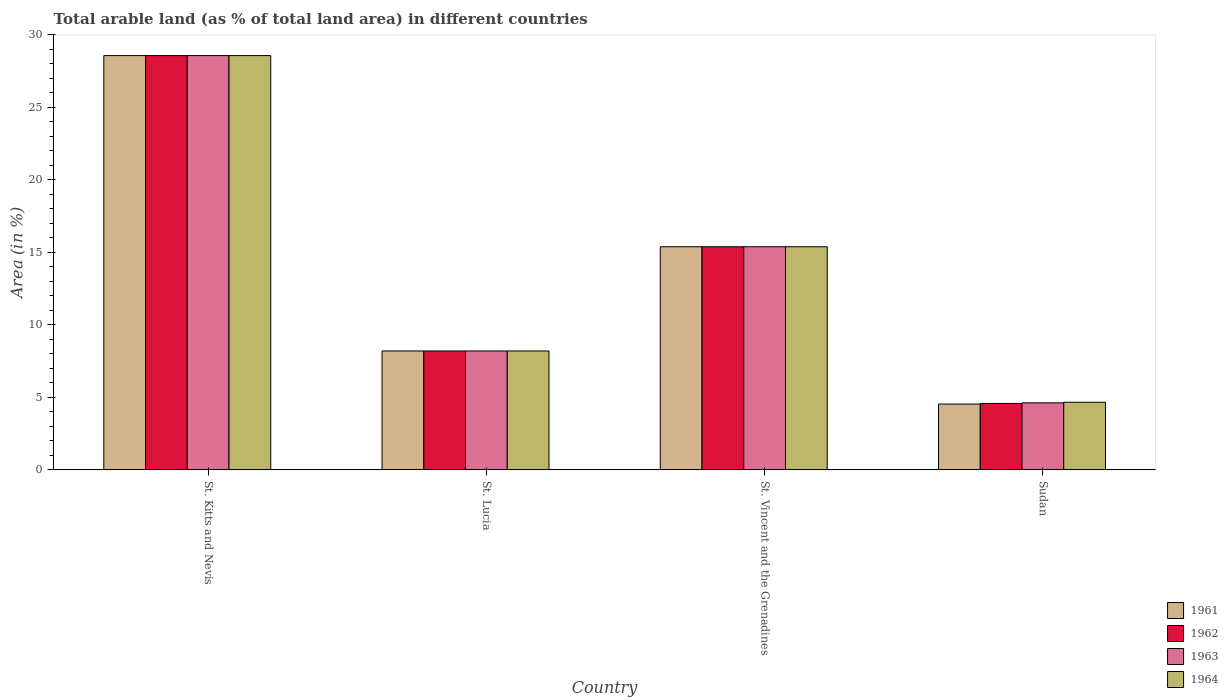How many different coloured bars are there?
Keep it short and to the point. 4. How many groups of bars are there?
Keep it short and to the point. 4. Are the number of bars per tick equal to the number of legend labels?
Offer a very short reply. Yes. How many bars are there on the 2nd tick from the left?
Ensure brevity in your answer.  4. What is the label of the 4th group of bars from the left?
Give a very brief answer. Sudan. In how many cases, is the number of bars for a given country not equal to the number of legend labels?
Provide a succinct answer. 0. What is the percentage of arable land in 1964 in St. Lucia?
Your response must be concise. 8.2. Across all countries, what is the maximum percentage of arable land in 1963?
Offer a terse response. 28.57. Across all countries, what is the minimum percentage of arable land in 1963?
Give a very brief answer. 4.62. In which country was the percentage of arable land in 1964 maximum?
Your answer should be compact. St. Kitts and Nevis. In which country was the percentage of arable land in 1963 minimum?
Give a very brief answer. Sudan. What is the total percentage of arable land in 1963 in the graph?
Make the answer very short. 56.77. What is the difference between the percentage of arable land in 1964 in St. Vincent and the Grenadines and that in Sudan?
Give a very brief answer. 10.72. What is the difference between the percentage of arable land in 1961 in St. Vincent and the Grenadines and the percentage of arable land in 1964 in St. Kitts and Nevis?
Make the answer very short. -13.19. What is the average percentage of arable land in 1963 per country?
Your answer should be very brief. 14.19. What is the difference between the percentage of arable land of/in 1961 and percentage of arable land of/in 1962 in Sudan?
Your answer should be compact. -0.04. In how many countries, is the percentage of arable land in 1964 greater than 23 %?
Your response must be concise. 1. What is the ratio of the percentage of arable land in 1961 in St. Lucia to that in St. Vincent and the Grenadines?
Ensure brevity in your answer.  0.53. What is the difference between the highest and the second highest percentage of arable land in 1962?
Provide a short and direct response. -20.37. What is the difference between the highest and the lowest percentage of arable land in 1961?
Provide a succinct answer. 24.04. In how many countries, is the percentage of arable land in 1964 greater than the average percentage of arable land in 1964 taken over all countries?
Your response must be concise. 2. Is the sum of the percentage of arable land in 1963 in St. Lucia and St. Vincent and the Grenadines greater than the maximum percentage of arable land in 1964 across all countries?
Keep it short and to the point. No. What does the 3rd bar from the left in St. Kitts and Nevis represents?
Your response must be concise. 1963. What does the 1st bar from the right in St. Lucia represents?
Your response must be concise. 1964. What is the difference between two consecutive major ticks on the Y-axis?
Give a very brief answer. 5. Does the graph contain any zero values?
Your answer should be very brief. No. What is the title of the graph?
Keep it short and to the point. Total arable land (as % of total land area) in different countries. What is the label or title of the X-axis?
Offer a very short reply. Country. What is the label or title of the Y-axis?
Keep it short and to the point. Area (in %). What is the Area (in %) of 1961 in St. Kitts and Nevis?
Offer a terse response. 28.57. What is the Area (in %) of 1962 in St. Kitts and Nevis?
Your answer should be compact. 28.57. What is the Area (in %) in 1963 in St. Kitts and Nevis?
Ensure brevity in your answer.  28.57. What is the Area (in %) of 1964 in St. Kitts and Nevis?
Your answer should be compact. 28.57. What is the Area (in %) in 1961 in St. Lucia?
Make the answer very short. 8.2. What is the Area (in %) in 1962 in St. Lucia?
Keep it short and to the point. 8.2. What is the Area (in %) of 1963 in St. Lucia?
Provide a short and direct response. 8.2. What is the Area (in %) of 1964 in St. Lucia?
Give a very brief answer. 8.2. What is the Area (in %) of 1961 in St. Vincent and the Grenadines?
Ensure brevity in your answer.  15.38. What is the Area (in %) in 1962 in St. Vincent and the Grenadines?
Offer a terse response. 15.38. What is the Area (in %) of 1963 in St. Vincent and the Grenadines?
Provide a short and direct response. 15.38. What is the Area (in %) of 1964 in St. Vincent and the Grenadines?
Your answer should be compact. 15.38. What is the Area (in %) of 1961 in Sudan?
Your response must be concise. 4.53. What is the Area (in %) of 1962 in Sudan?
Make the answer very short. 4.58. What is the Area (in %) in 1963 in Sudan?
Provide a succinct answer. 4.62. What is the Area (in %) in 1964 in Sudan?
Give a very brief answer. 4.66. Across all countries, what is the maximum Area (in %) of 1961?
Give a very brief answer. 28.57. Across all countries, what is the maximum Area (in %) of 1962?
Keep it short and to the point. 28.57. Across all countries, what is the maximum Area (in %) in 1963?
Provide a short and direct response. 28.57. Across all countries, what is the maximum Area (in %) in 1964?
Ensure brevity in your answer.  28.57. Across all countries, what is the minimum Area (in %) of 1961?
Provide a short and direct response. 4.53. Across all countries, what is the minimum Area (in %) of 1962?
Provide a succinct answer. 4.58. Across all countries, what is the minimum Area (in %) in 1963?
Give a very brief answer. 4.62. Across all countries, what is the minimum Area (in %) in 1964?
Your answer should be compact. 4.66. What is the total Area (in %) in 1961 in the graph?
Keep it short and to the point. 56.69. What is the total Area (in %) in 1962 in the graph?
Provide a short and direct response. 56.73. What is the total Area (in %) in 1963 in the graph?
Your response must be concise. 56.77. What is the total Area (in %) of 1964 in the graph?
Provide a succinct answer. 56.81. What is the difference between the Area (in %) of 1961 in St. Kitts and Nevis and that in St. Lucia?
Your answer should be compact. 20.37. What is the difference between the Area (in %) of 1962 in St. Kitts and Nevis and that in St. Lucia?
Provide a succinct answer. 20.37. What is the difference between the Area (in %) in 1963 in St. Kitts and Nevis and that in St. Lucia?
Your response must be concise. 20.37. What is the difference between the Area (in %) of 1964 in St. Kitts and Nevis and that in St. Lucia?
Your answer should be very brief. 20.37. What is the difference between the Area (in %) in 1961 in St. Kitts and Nevis and that in St. Vincent and the Grenadines?
Give a very brief answer. 13.19. What is the difference between the Area (in %) of 1962 in St. Kitts and Nevis and that in St. Vincent and the Grenadines?
Ensure brevity in your answer.  13.19. What is the difference between the Area (in %) in 1963 in St. Kitts and Nevis and that in St. Vincent and the Grenadines?
Provide a short and direct response. 13.19. What is the difference between the Area (in %) of 1964 in St. Kitts and Nevis and that in St. Vincent and the Grenadines?
Provide a short and direct response. 13.19. What is the difference between the Area (in %) of 1961 in St. Kitts and Nevis and that in Sudan?
Your response must be concise. 24.04. What is the difference between the Area (in %) in 1962 in St. Kitts and Nevis and that in Sudan?
Your answer should be very brief. 23.99. What is the difference between the Area (in %) in 1963 in St. Kitts and Nevis and that in Sudan?
Ensure brevity in your answer.  23.95. What is the difference between the Area (in %) in 1964 in St. Kitts and Nevis and that in Sudan?
Your answer should be very brief. 23.91. What is the difference between the Area (in %) in 1961 in St. Lucia and that in St. Vincent and the Grenadines?
Your response must be concise. -7.19. What is the difference between the Area (in %) in 1962 in St. Lucia and that in St. Vincent and the Grenadines?
Your response must be concise. -7.19. What is the difference between the Area (in %) of 1963 in St. Lucia and that in St. Vincent and the Grenadines?
Make the answer very short. -7.19. What is the difference between the Area (in %) of 1964 in St. Lucia and that in St. Vincent and the Grenadines?
Ensure brevity in your answer.  -7.19. What is the difference between the Area (in %) in 1961 in St. Lucia and that in Sudan?
Offer a very short reply. 3.66. What is the difference between the Area (in %) in 1962 in St. Lucia and that in Sudan?
Ensure brevity in your answer.  3.62. What is the difference between the Area (in %) in 1963 in St. Lucia and that in Sudan?
Provide a short and direct response. 3.58. What is the difference between the Area (in %) of 1964 in St. Lucia and that in Sudan?
Keep it short and to the point. 3.54. What is the difference between the Area (in %) in 1961 in St. Vincent and the Grenadines and that in Sudan?
Ensure brevity in your answer.  10.85. What is the difference between the Area (in %) of 1962 in St. Vincent and the Grenadines and that in Sudan?
Your answer should be compact. 10.81. What is the difference between the Area (in %) in 1963 in St. Vincent and the Grenadines and that in Sudan?
Give a very brief answer. 10.77. What is the difference between the Area (in %) in 1964 in St. Vincent and the Grenadines and that in Sudan?
Ensure brevity in your answer.  10.72. What is the difference between the Area (in %) of 1961 in St. Kitts and Nevis and the Area (in %) of 1962 in St. Lucia?
Your response must be concise. 20.37. What is the difference between the Area (in %) in 1961 in St. Kitts and Nevis and the Area (in %) in 1963 in St. Lucia?
Offer a very short reply. 20.37. What is the difference between the Area (in %) of 1961 in St. Kitts and Nevis and the Area (in %) of 1964 in St. Lucia?
Your answer should be very brief. 20.37. What is the difference between the Area (in %) of 1962 in St. Kitts and Nevis and the Area (in %) of 1963 in St. Lucia?
Offer a very short reply. 20.37. What is the difference between the Area (in %) of 1962 in St. Kitts and Nevis and the Area (in %) of 1964 in St. Lucia?
Your response must be concise. 20.37. What is the difference between the Area (in %) in 1963 in St. Kitts and Nevis and the Area (in %) in 1964 in St. Lucia?
Your answer should be compact. 20.37. What is the difference between the Area (in %) in 1961 in St. Kitts and Nevis and the Area (in %) in 1962 in St. Vincent and the Grenadines?
Offer a terse response. 13.19. What is the difference between the Area (in %) of 1961 in St. Kitts and Nevis and the Area (in %) of 1963 in St. Vincent and the Grenadines?
Your response must be concise. 13.19. What is the difference between the Area (in %) of 1961 in St. Kitts and Nevis and the Area (in %) of 1964 in St. Vincent and the Grenadines?
Your answer should be compact. 13.19. What is the difference between the Area (in %) of 1962 in St. Kitts and Nevis and the Area (in %) of 1963 in St. Vincent and the Grenadines?
Offer a terse response. 13.19. What is the difference between the Area (in %) of 1962 in St. Kitts and Nevis and the Area (in %) of 1964 in St. Vincent and the Grenadines?
Keep it short and to the point. 13.19. What is the difference between the Area (in %) of 1963 in St. Kitts and Nevis and the Area (in %) of 1964 in St. Vincent and the Grenadines?
Keep it short and to the point. 13.19. What is the difference between the Area (in %) in 1961 in St. Kitts and Nevis and the Area (in %) in 1962 in Sudan?
Make the answer very short. 23.99. What is the difference between the Area (in %) in 1961 in St. Kitts and Nevis and the Area (in %) in 1963 in Sudan?
Offer a terse response. 23.95. What is the difference between the Area (in %) in 1961 in St. Kitts and Nevis and the Area (in %) in 1964 in Sudan?
Offer a very short reply. 23.91. What is the difference between the Area (in %) in 1962 in St. Kitts and Nevis and the Area (in %) in 1963 in Sudan?
Make the answer very short. 23.95. What is the difference between the Area (in %) in 1962 in St. Kitts and Nevis and the Area (in %) in 1964 in Sudan?
Your answer should be very brief. 23.91. What is the difference between the Area (in %) in 1963 in St. Kitts and Nevis and the Area (in %) in 1964 in Sudan?
Make the answer very short. 23.91. What is the difference between the Area (in %) in 1961 in St. Lucia and the Area (in %) in 1962 in St. Vincent and the Grenadines?
Ensure brevity in your answer.  -7.19. What is the difference between the Area (in %) in 1961 in St. Lucia and the Area (in %) in 1963 in St. Vincent and the Grenadines?
Your answer should be very brief. -7.19. What is the difference between the Area (in %) in 1961 in St. Lucia and the Area (in %) in 1964 in St. Vincent and the Grenadines?
Your answer should be compact. -7.19. What is the difference between the Area (in %) in 1962 in St. Lucia and the Area (in %) in 1963 in St. Vincent and the Grenadines?
Keep it short and to the point. -7.19. What is the difference between the Area (in %) in 1962 in St. Lucia and the Area (in %) in 1964 in St. Vincent and the Grenadines?
Ensure brevity in your answer.  -7.19. What is the difference between the Area (in %) of 1963 in St. Lucia and the Area (in %) of 1964 in St. Vincent and the Grenadines?
Provide a short and direct response. -7.19. What is the difference between the Area (in %) in 1961 in St. Lucia and the Area (in %) in 1962 in Sudan?
Ensure brevity in your answer.  3.62. What is the difference between the Area (in %) in 1961 in St. Lucia and the Area (in %) in 1963 in Sudan?
Your response must be concise. 3.58. What is the difference between the Area (in %) of 1961 in St. Lucia and the Area (in %) of 1964 in Sudan?
Offer a very short reply. 3.54. What is the difference between the Area (in %) in 1962 in St. Lucia and the Area (in %) in 1963 in Sudan?
Make the answer very short. 3.58. What is the difference between the Area (in %) in 1962 in St. Lucia and the Area (in %) in 1964 in Sudan?
Give a very brief answer. 3.54. What is the difference between the Area (in %) of 1963 in St. Lucia and the Area (in %) of 1964 in Sudan?
Your answer should be very brief. 3.54. What is the difference between the Area (in %) in 1961 in St. Vincent and the Grenadines and the Area (in %) in 1962 in Sudan?
Your answer should be compact. 10.81. What is the difference between the Area (in %) of 1961 in St. Vincent and the Grenadines and the Area (in %) of 1963 in Sudan?
Give a very brief answer. 10.77. What is the difference between the Area (in %) of 1961 in St. Vincent and the Grenadines and the Area (in %) of 1964 in Sudan?
Your answer should be compact. 10.72. What is the difference between the Area (in %) of 1962 in St. Vincent and the Grenadines and the Area (in %) of 1963 in Sudan?
Provide a short and direct response. 10.77. What is the difference between the Area (in %) of 1962 in St. Vincent and the Grenadines and the Area (in %) of 1964 in Sudan?
Provide a short and direct response. 10.72. What is the difference between the Area (in %) in 1963 in St. Vincent and the Grenadines and the Area (in %) in 1964 in Sudan?
Make the answer very short. 10.72. What is the average Area (in %) of 1961 per country?
Offer a very short reply. 14.17. What is the average Area (in %) of 1962 per country?
Provide a succinct answer. 14.18. What is the average Area (in %) in 1963 per country?
Your answer should be very brief. 14.19. What is the average Area (in %) of 1964 per country?
Keep it short and to the point. 14.2. What is the difference between the Area (in %) in 1962 and Area (in %) in 1963 in St. Kitts and Nevis?
Offer a very short reply. 0. What is the difference between the Area (in %) of 1962 and Area (in %) of 1964 in St. Kitts and Nevis?
Make the answer very short. 0. What is the difference between the Area (in %) in 1961 and Area (in %) in 1962 in St. Lucia?
Ensure brevity in your answer.  0. What is the difference between the Area (in %) of 1961 and Area (in %) of 1963 in St. Lucia?
Your answer should be very brief. 0. What is the difference between the Area (in %) in 1961 and Area (in %) in 1964 in St. Lucia?
Keep it short and to the point. 0. What is the difference between the Area (in %) of 1962 and Area (in %) of 1964 in St. Lucia?
Keep it short and to the point. 0. What is the difference between the Area (in %) in 1961 and Area (in %) in 1962 in St. Vincent and the Grenadines?
Ensure brevity in your answer.  0. What is the difference between the Area (in %) of 1961 and Area (in %) of 1963 in St. Vincent and the Grenadines?
Offer a very short reply. 0. What is the difference between the Area (in %) in 1962 and Area (in %) in 1963 in St. Vincent and the Grenadines?
Your response must be concise. 0. What is the difference between the Area (in %) in 1962 and Area (in %) in 1964 in St. Vincent and the Grenadines?
Offer a terse response. 0. What is the difference between the Area (in %) in 1963 and Area (in %) in 1964 in St. Vincent and the Grenadines?
Your answer should be very brief. 0. What is the difference between the Area (in %) in 1961 and Area (in %) in 1962 in Sudan?
Your answer should be compact. -0.04. What is the difference between the Area (in %) of 1961 and Area (in %) of 1963 in Sudan?
Provide a short and direct response. -0.08. What is the difference between the Area (in %) of 1961 and Area (in %) of 1964 in Sudan?
Provide a short and direct response. -0.12. What is the difference between the Area (in %) in 1962 and Area (in %) in 1963 in Sudan?
Make the answer very short. -0.04. What is the difference between the Area (in %) of 1962 and Area (in %) of 1964 in Sudan?
Ensure brevity in your answer.  -0.08. What is the difference between the Area (in %) of 1963 and Area (in %) of 1964 in Sudan?
Give a very brief answer. -0.04. What is the ratio of the Area (in %) of 1961 in St. Kitts and Nevis to that in St. Lucia?
Your answer should be very brief. 3.49. What is the ratio of the Area (in %) in 1962 in St. Kitts and Nevis to that in St. Lucia?
Offer a very short reply. 3.49. What is the ratio of the Area (in %) in 1963 in St. Kitts and Nevis to that in St. Lucia?
Offer a very short reply. 3.49. What is the ratio of the Area (in %) in 1964 in St. Kitts and Nevis to that in St. Lucia?
Make the answer very short. 3.49. What is the ratio of the Area (in %) of 1961 in St. Kitts and Nevis to that in St. Vincent and the Grenadines?
Provide a succinct answer. 1.86. What is the ratio of the Area (in %) in 1962 in St. Kitts and Nevis to that in St. Vincent and the Grenadines?
Your response must be concise. 1.86. What is the ratio of the Area (in %) of 1963 in St. Kitts and Nevis to that in St. Vincent and the Grenadines?
Your answer should be compact. 1.86. What is the ratio of the Area (in %) of 1964 in St. Kitts and Nevis to that in St. Vincent and the Grenadines?
Ensure brevity in your answer.  1.86. What is the ratio of the Area (in %) of 1961 in St. Kitts and Nevis to that in Sudan?
Give a very brief answer. 6.3. What is the ratio of the Area (in %) of 1962 in St. Kitts and Nevis to that in Sudan?
Your answer should be very brief. 6.24. What is the ratio of the Area (in %) in 1963 in St. Kitts and Nevis to that in Sudan?
Your answer should be very brief. 6.19. What is the ratio of the Area (in %) of 1964 in St. Kitts and Nevis to that in Sudan?
Your response must be concise. 6.13. What is the ratio of the Area (in %) of 1961 in St. Lucia to that in St. Vincent and the Grenadines?
Provide a succinct answer. 0.53. What is the ratio of the Area (in %) of 1962 in St. Lucia to that in St. Vincent and the Grenadines?
Make the answer very short. 0.53. What is the ratio of the Area (in %) of 1963 in St. Lucia to that in St. Vincent and the Grenadines?
Give a very brief answer. 0.53. What is the ratio of the Area (in %) in 1964 in St. Lucia to that in St. Vincent and the Grenadines?
Your answer should be compact. 0.53. What is the ratio of the Area (in %) of 1961 in St. Lucia to that in Sudan?
Make the answer very short. 1.81. What is the ratio of the Area (in %) of 1962 in St. Lucia to that in Sudan?
Ensure brevity in your answer.  1.79. What is the ratio of the Area (in %) in 1963 in St. Lucia to that in Sudan?
Keep it short and to the point. 1.77. What is the ratio of the Area (in %) in 1964 in St. Lucia to that in Sudan?
Provide a short and direct response. 1.76. What is the ratio of the Area (in %) in 1961 in St. Vincent and the Grenadines to that in Sudan?
Keep it short and to the point. 3.39. What is the ratio of the Area (in %) of 1962 in St. Vincent and the Grenadines to that in Sudan?
Your answer should be very brief. 3.36. What is the ratio of the Area (in %) of 1963 in St. Vincent and the Grenadines to that in Sudan?
Provide a succinct answer. 3.33. What is the ratio of the Area (in %) of 1964 in St. Vincent and the Grenadines to that in Sudan?
Provide a succinct answer. 3.3. What is the difference between the highest and the second highest Area (in %) in 1961?
Make the answer very short. 13.19. What is the difference between the highest and the second highest Area (in %) in 1962?
Your response must be concise. 13.19. What is the difference between the highest and the second highest Area (in %) of 1963?
Make the answer very short. 13.19. What is the difference between the highest and the second highest Area (in %) of 1964?
Make the answer very short. 13.19. What is the difference between the highest and the lowest Area (in %) in 1961?
Provide a short and direct response. 24.04. What is the difference between the highest and the lowest Area (in %) in 1962?
Give a very brief answer. 23.99. What is the difference between the highest and the lowest Area (in %) in 1963?
Ensure brevity in your answer.  23.95. What is the difference between the highest and the lowest Area (in %) in 1964?
Keep it short and to the point. 23.91. 